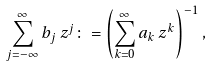<formula> <loc_0><loc_0><loc_500><loc_500>\sum _ { j = - \infty } ^ { \infty } b _ { j } \, z ^ { j } \colon = \left ( \sum _ { k = 0 } ^ { \infty } a _ { k } \, z ^ { k } \right ) ^ { - 1 } ,</formula> 